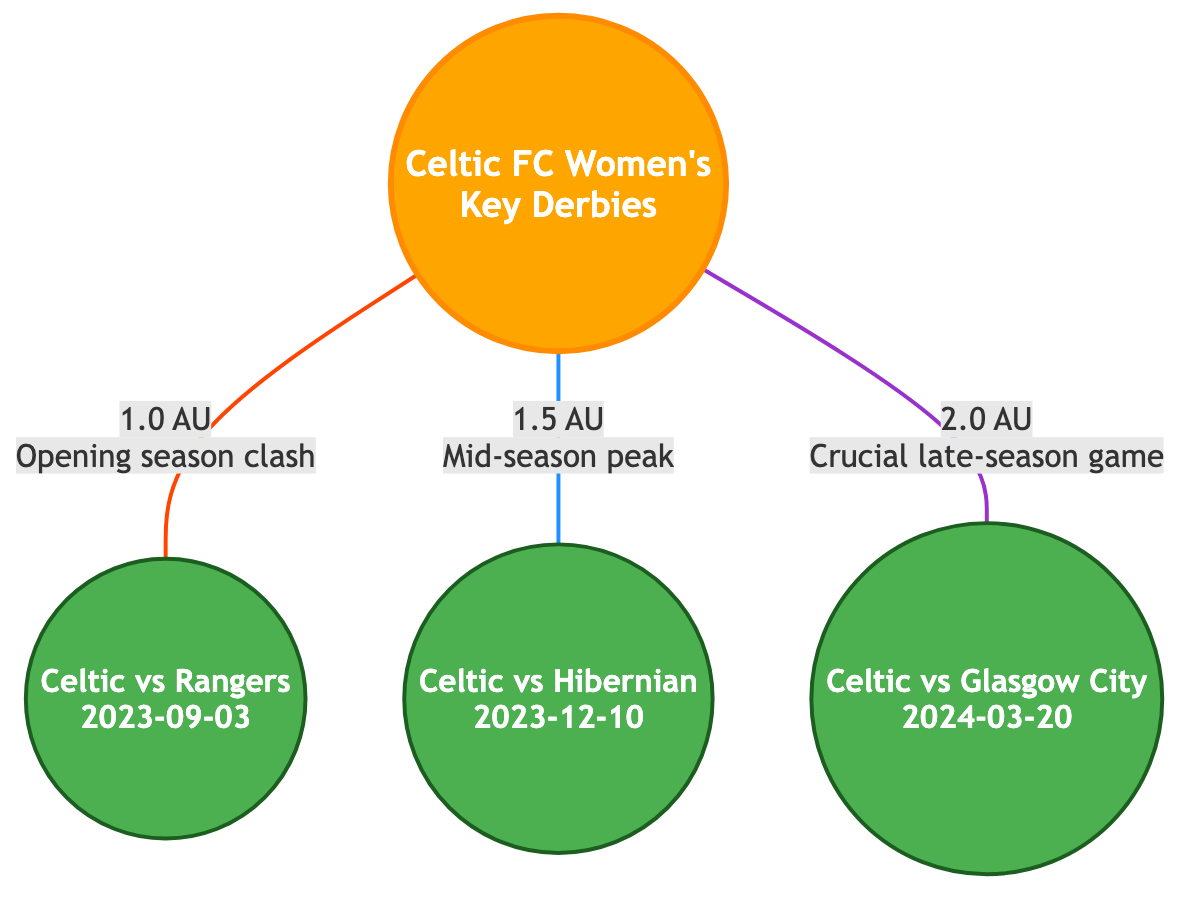What is the first derby date mentioned in the diagram? The diagram lists three key derby dates. The first one is between Celtic and Rangers on September 3, 2023, which is the earliest date shown in the diagram.
Answer: September 3, 2023 How many key derby matches are represented in the diagram? The diagram features three matches: Celtic vs Rangers, Celtic vs Hibernian, and Celtic vs Glasgow City. Counting these matches gives a total of three key derby matches.
Answer: 3 What is the distance of the match against Hibernian from the Sun? The diagram shows that the match against Hibernian, which takes place on December 10, 2023, is located 1.5 AU away from the Sun. This distance is explicitly indicated by the link in the diagram.
Answer: 1.5 AU Which team faces Celtic in the last derby of the season? The last derby represented in the diagram is against Glasgow City on March 20, 2024. This denotes the final match shown in this timeline of key derbies.
Answer: Glasgow City What color is used to represent the Sun in the diagram? The Sun is colored in a shade of orange as indicated by the class definition in the diagram. Specifically, it uses the fill color #FFA500 for the Sun's representation, highlighting its importance.
Answer: Orange Which derby match is indicated as a mid-season peak? The derby match against Hibernian, scheduled for December 10, 2023, is marked with a comment "Mid-season peak," distinguishing it within the set of key matches depicted.
Answer: Hibernian 